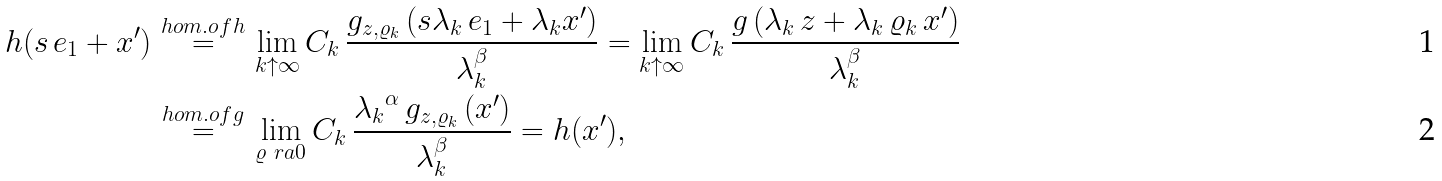Convert formula to latex. <formula><loc_0><loc_0><loc_500><loc_500>h ( s \, e _ { 1 } + x ^ { \prime } ) \quad & \stackrel { \mathclap { h o m . o f h } } { = } \quad \lim _ { k \uparrow \infty } C _ { k } \, \frac { g _ { z , \varrho _ { k } } \left ( s \lambda _ { k } \, e _ { 1 } + \lambda _ { k } x ^ { \prime } \right ) } { \lambda _ { k } ^ { \beta } } = \lim _ { k \uparrow \infty } C _ { k } \, \frac { g \left ( \lambda _ { k } \, z + \lambda _ { k } \, \varrho _ { k } \, x ^ { \prime } \right ) } { \lambda _ { k } ^ { \beta } } \\ & \stackrel { \mathclap { h o m . o f g } } { = } \quad \lim _ { \varrho \ r a 0 } C _ { k } \, \frac { { \lambda _ { k } } ^ { \alpha } \, g _ { z , \varrho _ { k } } \left ( x ^ { \prime } \right ) } { \lambda _ { k } ^ { \beta } } = h ( x ^ { \prime } ) ,</formula> 